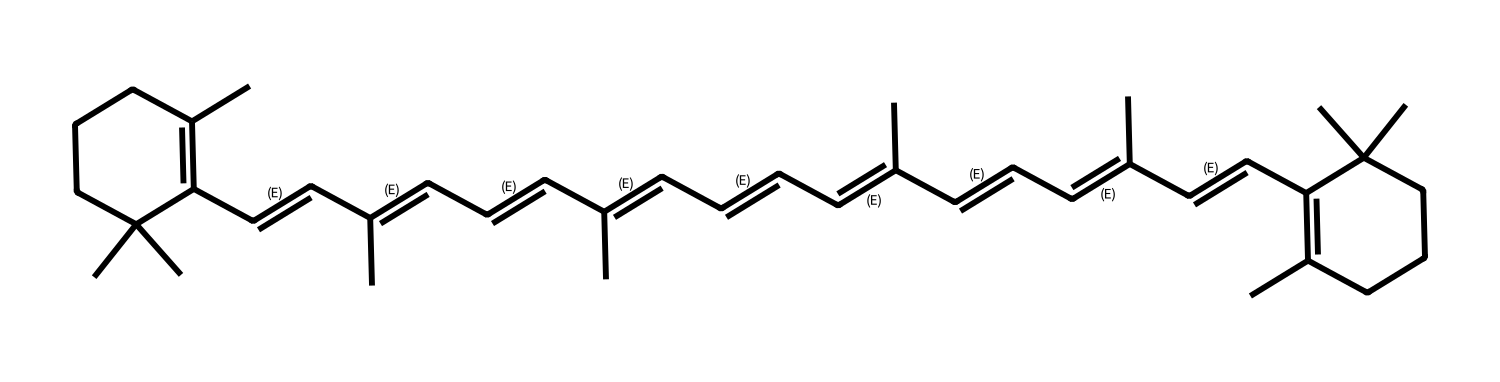What is the total number of carbon atoms in the structure? By analyzing the SMILES representation, we count the 'C' characters. Each 'C' represents a carbon atom. Counting carefully, we find there are 40 carbon atoms in total in this structure.
Answer: 40 How many double bonds are present in the chemical structure? The presence of double bonds can be inferred from the occurrences of '=' in the SMILES notation. By counting these occurrences, we find there are 9 double bonds in the structure.
Answer: 9 What is the primary function of carotenoids in plants? Carotenoids serve primarily as pigments that aid in photosynthesis and protect plants from damage caused by excessive sunlight. This is a well-established role of carotenoids in plant biology.
Answer: pigments Which specific geometric isomers can exist for this compound? Given that this compound has several C=C double bonds, it can have geometric isomers such as cis and trans forms. Each double bond can potentially exist in either of these configurations, leading to multiple geometric isomers overall.
Answer: cis and trans forms What are the visual characteristics of the carotenoid pigments? Carotenoid pigments are typically orange, yellow, or red in color. These colors arise from their specific conjugated double bond systems that can absorb light in the blue and violet wavelengths.
Answer: orange, yellow, red How does the number of double bonds affect the geometrical isomerism of this compound? The presence of multiple double bonds allows for different spatial arrangements (cis/trans) around each bond, increasing the possibilities for isomerism. Each C=C bond contributes to the overall complexity of potential isomers, thus enhancing diversity in the compound's forms.
Answer: increases diversity 